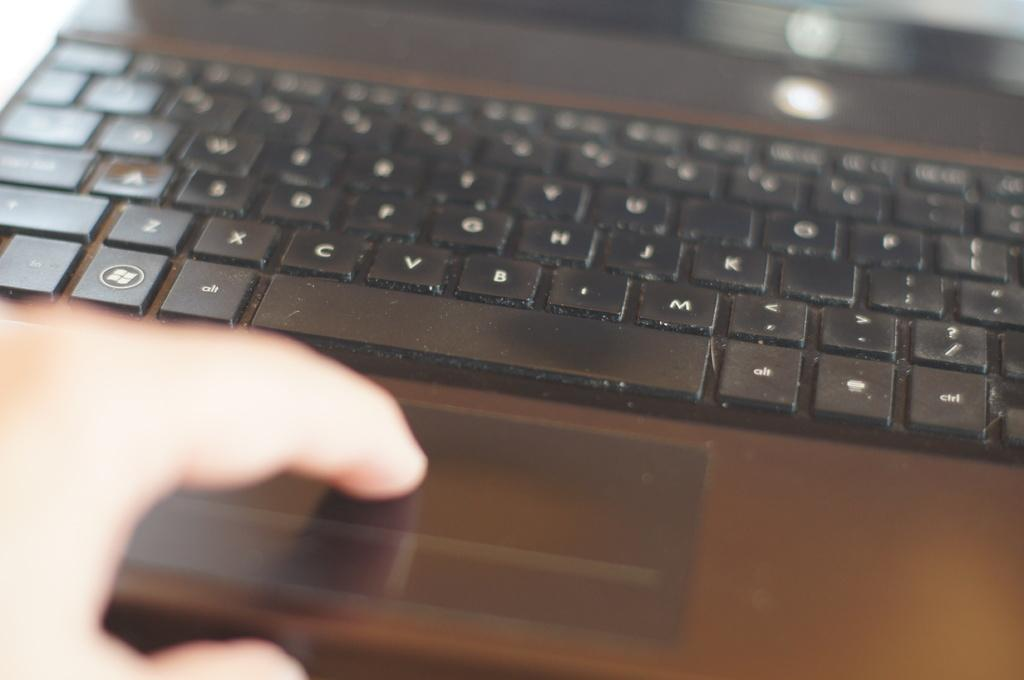Provide a one-sentence caption for the provided image. Person pressing the space bar on a laptop with an Alt key right above. 